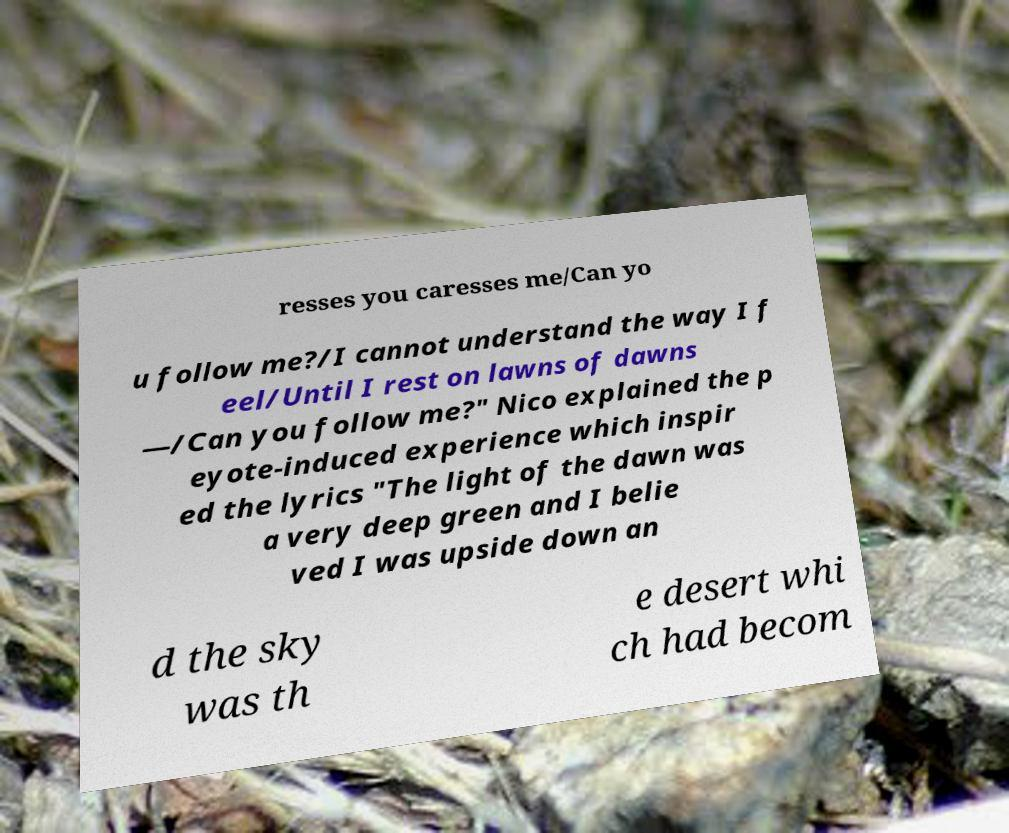I need the written content from this picture converted into text. Can you do that? resses you caresses me/Can yo u follow me?/I cannot understand the way I f eel/Until I rest on lawns of dawns —/Can you follow me?" Nico explained the p eyote-induced experience which inspir ed the lyrics "The light of the dawn was a very deep green and I belie ved I was upside down an d the sky was th e desert whi ch had becom 